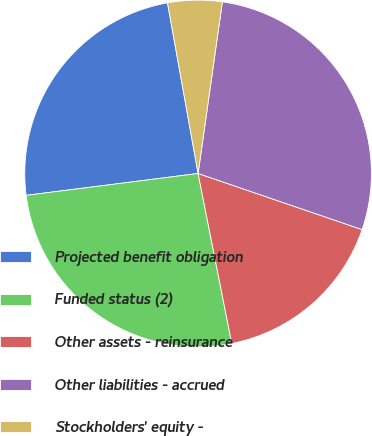Convert chart. <chart><loc_0><loc_0><loc_500><loc_500><pie_chart><fcel>Projected benefit obligation<fcel>Funded status (2)<fcel>Other assets - reinsurance<fcel>Other liabilities - accrued<fcel>Stockholders' equity -<nl><fcel>24.19%<fcel>26.1%<fcel>16.64%<fcel>28.01%<fcel>5.06%<nl></chart> 